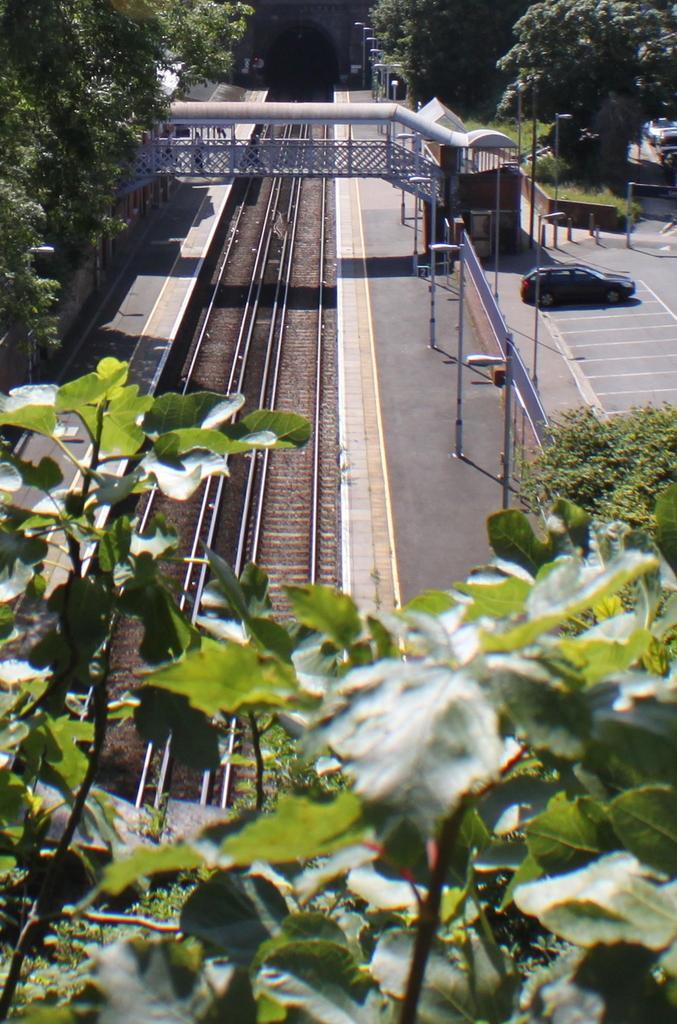How would you summarize this image in a sentence or two? In this image in the front there are leaves. In the center there are railway tracks. On the right side there is a car on the road. In the background there is a foot over bridge and there are trees and on the right side there is a fence and there are poles. 